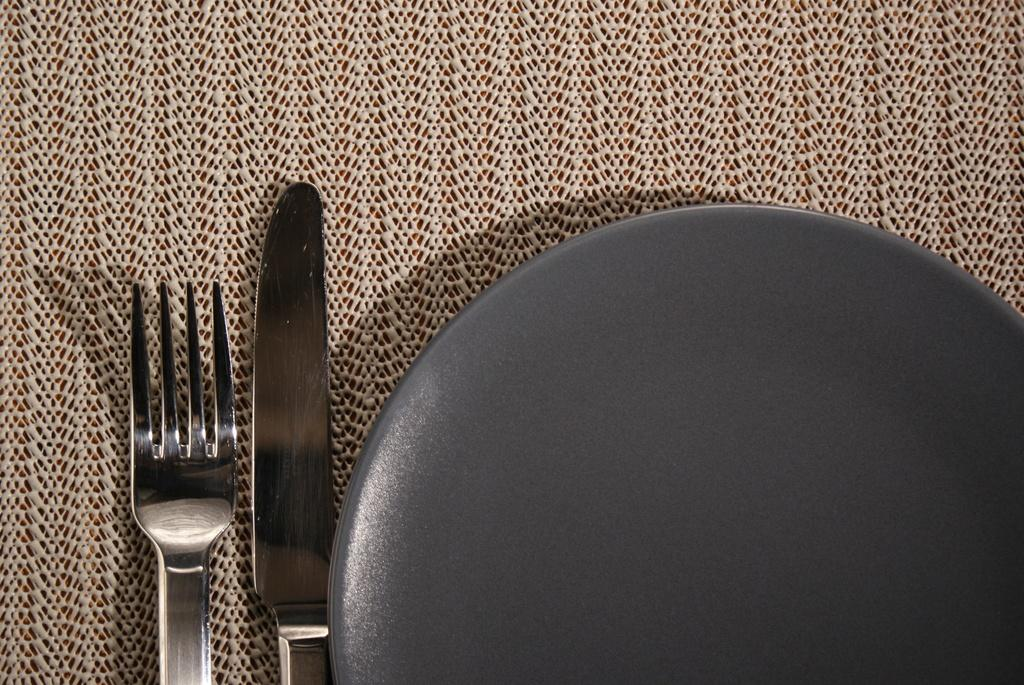What type of dishware is present in the image? There is a gray plate in the image. What utensils can be seen in the image? There is a knife and a fork in the image. What is placed under the plate in the image? There is a table mat in the image. How many kittens are playing on the table in the image? There are no kittens present in the image; it only features a gray plate, a knife, a fork, and a table mat. 